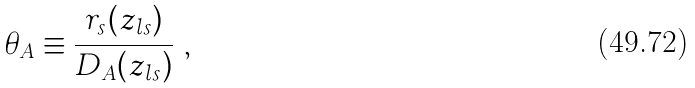Convert formula to latex. <formula><loc_0><loc_0><loc_500><loc_500>\theta _ { A } \equiv \frac { r _ { s } ( z _ { l s } ) } { D _ { A } ( z _ { l s } ) } \ ,</formula> 